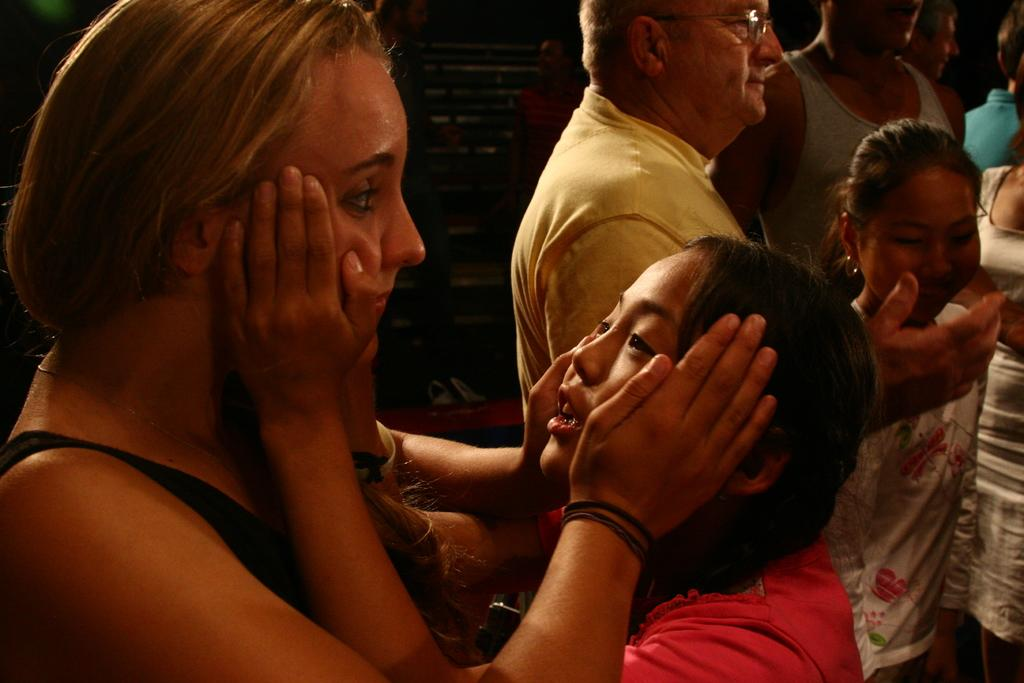How many girls are in the foreground of the image? There are two girls in the foreground of the image. Can you describe the people behind the girls? There are other people visible behind the girls. What type of yak can be seen in the image? There is no yak present in the image. What thoughts are the girls having in the image? We cannot determine the thoughts of the girls from the image alone. 